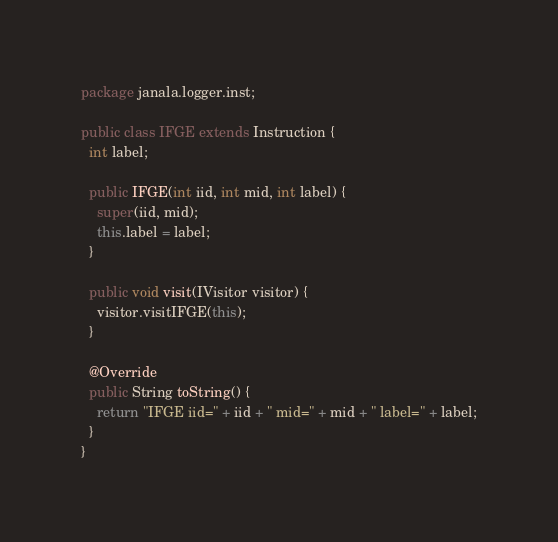Convert code to text. <code><loc_0><loc_0><loc_500><loc_500><_Java_>package janala.logger.inst;

public class IFGE extends Instruction {
  int label;

  public IFGE(int iid, int mid, int label) {
    super(iid, mid);
    this.label = label;
  }

  public void visit(IVisitor visitor) {
    visitor.visitIFGE(this);
  }

  @Override
  public String toString() {
    return "IFGE iid=" + iid + " mid=" + mid + " label=" + label;
  }
}
</code> 